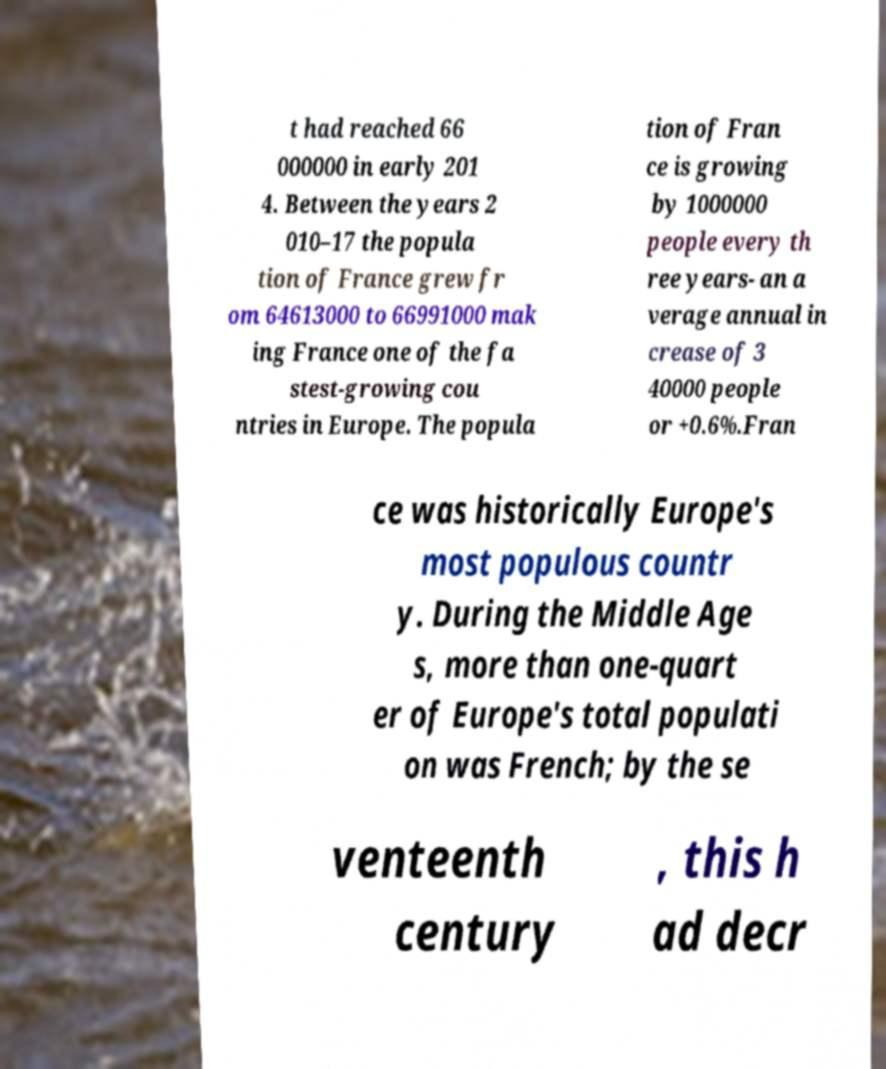Please read and relay the text visible in this image. What does it say? t had reached 66 000000 in early 201 4. Between the years 2 010–17 the popula tion of France grew fr om 64613000 to 66991000 mak ing France one of the fa stest-growing cou ntries in Europe. The popula tion of Fran ce is growing by 1000000 people every th ree years- an a verage annual in crease of 3 40000 people or +0.6%.Fran ce was historically Europe's most populous countr y. During the Middle Age s, more than one-quart er of Europe's total populati on was French; by the se venteenth century , this h ad decr 